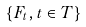<formula> <loc_0><loc_0><loc_500><loc_500>\{ F _ { t } , t \in T \}</formula> 